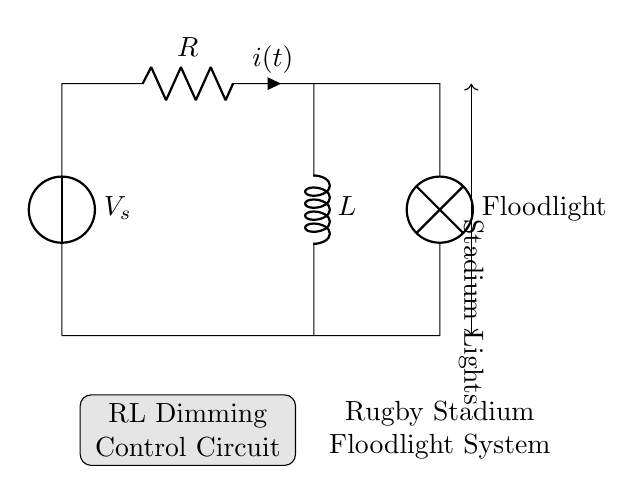What are the components in this circuit? The circuit contains a voltage source, a resistor, an inductor, and a floodlight. These components are depicted clearly and labeled in the diagram.
Answer: voltage source, resistor, inductor, floodlight What is the purpose of the resistor in this RL circuit? The resistor limits the current flow and dissipates energy as heat, which is critical for controlling the brightness of the floodlights.
Answer: current limiting What is the role of the inductor in this circuit? The inductor stores energy in a magnetic field when current flows through it and influences the circuit's response to changes in current, which helps in dimming the floodlights gradually.
Answer: energy storage How does the circuit respond to a sudden increase in voltage? A sudden increase in voltage causes the current to rise, but the inductor opposes this change by inducing a back electromotive force, resulting in a delayed current increase.
Answer: delayed current increase What happens to the total current when the resistance increases? Increasing the resistance reduces the total current in the circuit, based on Ohm's law, where current is inversely proportional to resistance.
Answer: decreases What type of circuit is shown in the diagram? The diagram depicts an RL (Resistor-Inductor) circuit, which is characterized by having both a resistor and an inductor connected in series or parallel, typically used for applications like dimming control.
Answer: RL circuit 